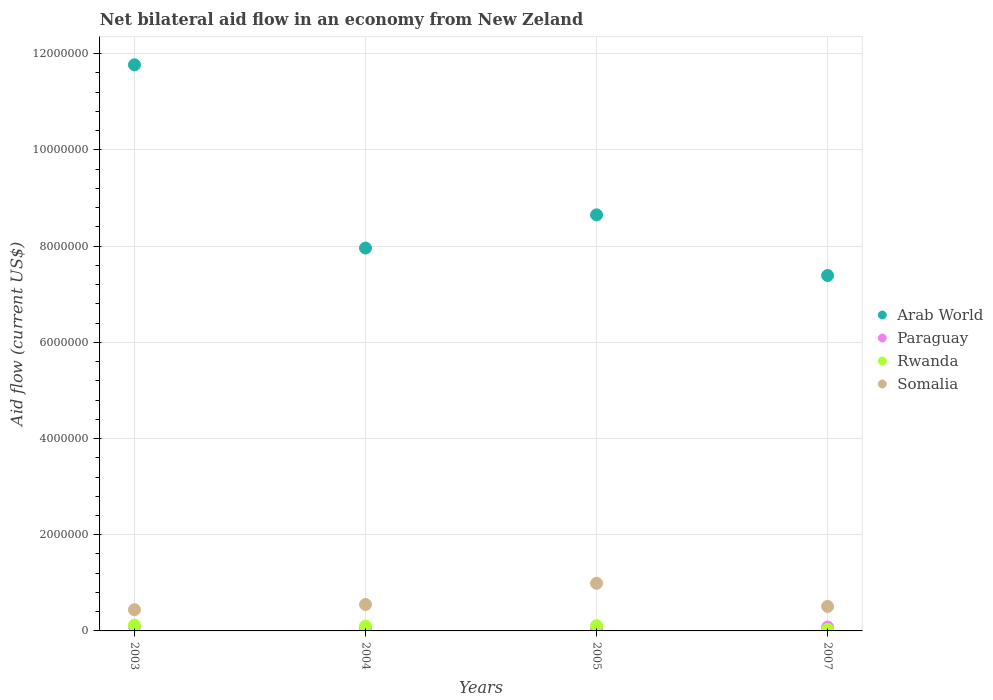How many different coloured dotlines are there?
Keep it short and to the point. 4. Is the number of dotlines equal to the number of legend labels?
Your response must be concise. Yes. What is the net bilateral aid flow in Paraguay in 2003?
Offer a very short reply. 9.00e+04. Across all years, what is the maximum net bilateral aid flow in Rwanda?
Keep it short and to the point. 1.20e+05. Across all years, what is the minimum net bilateral aid flow in Arab World?
Your answer should be very brief. 7.39e+06. In which year was the net bilateral aid flow in Paraguay maximum?
Your answer should be very brief. 2003. What is the total net bilateral aid flow in Somalia in the graph?
Your response must be concise. 2.49e+06. What is the difference between the net bilateral aid flow in Rwanda in 2005 and that in 2007?
Your response must be concise. 8.00e+04. What is the difference between the net bilateral aid flow in Somalia in 2004 and the net bilateral aid flow in Paraguay in 2007?
Your answer should be compact. 4.70e+05. In the year 2007, what is the difference between the net bilateral aid flow in Somalia and net bilateral aid flow in Arab World?
Provide a succinct answer. -6.88e+06. What is the ratio of the net bilateral aid flow in Rwanda in 2003 to that in 2005?
Your answer should be compact. 1.09. Is the difference between the net bilateral aid flow in Somalia in 2003 and 2005 greater than the difference between the net bilateral aid flow in Arab World in 2003 and 2005?
Ensure brevity in your answer.  No. In how many years, is the net bilateral aid flow in Arab World greater than the average net bilateral aid flow in Arab World taken over all years?
Make the answer very short. 1. Is the sum of the net bilateral aid flow in Rwanda in 2004 and 2005 greater than the maximum net bilateral aid flow in Somalia across all years?
Make the answer very short. No. Is it the case that in every year, the sum of the net bilateral aid flow in Somalia and net bilateral aid flow in Rwanda  is greater than the sum of net bilateral aid flow in Paraguay and net bilateral aid flow in Arab World?
Your answer should be very brief. No. Is it the case that in every year, the sum of the net bilateral aid flow in Arab World and net bilateral aid flow in Somalia  is greater than the net bilateral aid flow in Rwanda?
Ensure brevity in your answer.  Yes. Does the net bilateral aid flow in Paraguay monotonically increase over the years?
Your answer should be compact. No. Is the net bilateral aid flow in Somalia strictly greater than the net bilateral aid flow in Paraguay over the years?
Your response must be concise. Yes. What is the difference between two consecutive major ticks on the Y-axis?
Your answer should be very brief. 2.00e+06. Are the values on the major ticks of Y-axis written in scientific E-notation?
Your answer should be very brief. No. Does the graph contain any zero values?
Provide a short and direct response. No. Does the graph contain grids?
Your response must be concise. Yes. How many legend labels are there?
Offer a very short reply. 4. What is the title of the graph?
Your answer should be very brief. Net bilateral aid flow in an economy from New Zeland. Does "Turks and Caicos Islands" appear as one of the legend labels in the graph?
Keep it short and to the point. No. What is the Aid flow (current US$) in Arab World in 2003?
Ensure brevity in your answer.  1.18e+07. What is the Aid flow (current US$) of Paraguay in 2003?
Your answer should be very brief. 9.00e+04. What is the Aid flow (current US$) of Rwanda in 2003?
Give a very brief answer. 1.20e+05. What is the Aid flow (current US$) of Arab World in 2004?
Provide a short and direct response. 7.96e+06. What is the Aid flow (current US$) of Paraguay in 2004?
Provide a short and direct response. 6.00e+04. What is the Aid flow (current US$) in Rwanda in 2004?
Ensure brevity in your answer.  1.00e+05. What is the Aid flow (current US$) in Arab World in 2005?
Ensure brevity in your answer.  8.65e+06. What is the Aid flow (current US$) of Paraguay in 2005?
Offer a very short reply. 5.00e+04. What is the Aid flow (current US$) in Rwanda in 2005?
Make the answer very short. 1.10e+05. What is the Aid flow (current US$) of Somalia in 2005?
Offer a very short reply. 9.90e+05. What is the Aid flow (current US$) of Arab World in 2007?
Offer a terse response. 7.39e+06. What is the Aid flow (current US$) in Paraguay in 2007?
Your answer should be very brief. 8.00e+04. What is the Aid flow (current US$) of Somalia in 2007?
Offer a terse response. 5.10e+05. Across all years, what is the maximum Aid flow (current US$) of Arab World?
Keep it short and to the point. 1.18e+07. Across all years, what is the maximum Aid flow (current US$) in Paraguay?
Ensure brevity in your answer.  9.00e+04. Across all years, what is the maximum Aid flow (current US$) in Somalia?
Offer a terse response. 9.90e+05. Across all years, what is the minimum Aid flow (current US$) in Arab World?
Keep it short and to the point. 7.39e+06. Across all years, what is the minimum Aid flow (current US$) of Rwanda?
Offer a terse response. 3.00e+04. What is the total Aid flow (current US$) in Arab World in the graph?
Ensure brevity in your answer.  3.58e+07. What is the total Aid flow (current US$) of Paraguay in the graph?
Ensure brevity in your answer.  2.80e+05. What is the total Aid flow (current US$) of Somalia in the graph?
Your answer should be compact. 2.49e+06. What is the difference between the Aid flow (current US$) of Arab World in 2003 and that in 2004?
Ensure brevity in your answer.  3.81e+06. What is the difference between the Aid flow (current US$) in Rwanda in 2003 and that in 2004?
Provide a succinct answer. 2.00e+04. What is the difference between the Aid flow (current US$) in Somalia in 2003 and that in 2004?
Keep it short and to the point. -1.10e+05. What is the difference between the Aid flow (current US$) in Arab World in 2003 and that in 2005?
Your answer should be compact. 3.12e+06. What is the difference between the Aid flow (current US$) in Paraguay in 2003 and that in 2005?
Your response must be concise. 4.00e+04. What is the difference between the Aid flow (current US$) in Somalia in 2003 and that in 2005?
Make the answer very short. -5.50e+05. What is the difference between the Aid flow (current US$) in Arab World in 2003 and that in 2007?
Offer a very short reply. 4.38e+06. What is the difference between the Aid flow (current US$) in Rwanda in 2003 and that in 2007?
Keep it short and to the point. 9.00e+04. What is the difference between the Aid flow (current US$) of Somalia in 2003 and that in 2007?
Ensure brevity in your answer.  -7.00e+04. What is the difference between the Aid flow (current US$) in Arab World in 2004 and that in 2005?
Ensure brevity in your answer.  -6.90e+05. What is the difference between the Aid flow (current US$) in Paraguay in 2004 and that in 2005?
Your response must be concise. 10000. What is the difference between the Aid flow (current US$) in Rwanda in 2004 and that in 2005?
Your answer should be compact. -10000. What is the difference between the Aid flow (current US$) of Somalia in 2004 and that in 2005?
Keep it short and to the point. -4.40e+05. What is the difference between the Aid flow (current US$) in Arab World in 2004 and that in 2007?
Your answer should be compact. 5.70e+05. What is the difference between the Aid flow (current US$) of Rwanda in 2004 and that in 2007?
Give a very brief answer. 7.00e+04. What is the difference between the Aid flow (current US$) of Somalia in 2004 and that in 2007?
Provide a succinct answer. 4.00e+04. What is the difference between the Aid flow (current US$) in Arab World in 2005 and that in 2007?
Make the answer very short. 1.26e+06. What is the difference between the Aid flow (current US$) of Rwanda in 2005 and that in 2007?
Offer a very short reply. 8.00e+04. What is the difference between the Aid flow (current US$) in Arab World in 2003 and the Aid flow (current US$) in Paraguay in 2004?
Make the answer very short. 1.17e+07. What is the difference between the Aid flow (current US$) of Arab World in 2003 and the Aid flow (current US$) of Rwanda in 2004?
Offer a terse response. 1.17e+07. What is the difference between the Aid flow (current US$) of Arab World in 2003 and the Aid flow (current US$) of Somalia in 2004?
Your answer should be very brief. 1.12e+07. What is the difference between the Aid flow (current US$) in Paraguay in 2003 and the Aid flow (current US$) in Rwanda in 2004?
Your answer should be compact. -10000. What is the difference between the Aid flow (current US$) of Paraguay in 2003 and the Aid flow (current US$) of Somalia in 2004?
Offer a terse response. -4.60e+05. What is the difference between the Aid flow (current US$) of Rwanda in 2003 and the Aid flow (current US$) of Somalia in 2004?
Give a very brief answer. -4.30e+05. What is the difference between the Aid flow (current US$) in Arab World in 2003 and the Aid flow (current US$) in Paraguay in 2005?
Offer a terse response. 1.17e+07. What is the difference between the Aid flow (current US$) in Arab World in 2003 and the Aid flow (current US$) in Rwanda in 2005?
Offer a terse response. 1.17e+07. What is the difference between the Aid flow (current US$) in Arab World in 2003 and the Aid flow (current US$) in Somalia in 2005?
Your response must be concise. 1.08e+07. What is the difference between the Aid flow (current US$) in Paraguay in 2003 and the Aid flow (current US$) in Rwanda in 2005?
Give a very brief answer. -2.00e+04. What is the difference between the Aid flow (current US$) in Paraguay in 2003 and the Aid flow (current US$) in Somalia in 2005?
Offer a terse response. -9.00e+05. What is the difference between the Aid flow (current US$) of Rwanda in 2003 and the Aid flow (current US$) of Somalia in 2005?
Offer a terse response. -8.70e+05. What is the difference between the Aid flow (current US$) in Arab World in 2003 and the Aid flow (current US$) in Paraguay in 2007?
Make the answer very short. 1.17e+07. What is the difference between the Aid flow (current US$) in Arab World in 2003 and the Aid flow (current US$) in Rwanda in 2007?
Provide a succinct answer. 1.17e+07. What is the difference between the Aid flow (current US$) of Arab World in 2003 and the Aid flow (current US$) of Somalia in 2007?
Provide a short and direct response. 1.13e+07. What is the difference between the Aid flow (current US$) of Paraguay in 2003 and the Aid flow (current US$) of Somalia in 2007?
Your response must be concise. -4.20e+05. What is the difference between the Aid flow (current US$) of Rwanda in 2003 and the Aid flow (current US$) of Somalia in 2007?
Keep it short and to the point. -3.90e+05. What is the difference between the Aid flow (current US$) of Arab World in 2004 and the Aid flow (current US$) of Paraguay in 2005?
Provide a succinct answer. 7.91e+06. What is the difference between the Aid flow (current US$) of Arab World in 2004 and the Aid flow (current US$) of Rwanda in 2005?
Keep it short and to the point. 7.85e+06. What is the difference between the Aid flow (current US$) of Arab World in 2004 and the Aid flow (current US$) of Somalia in 2005?
Give a very brief answer. 6.97e+06. What is the difference between the Aid flow (current US$) of Paraguay in 2004 and the Aid flow (current US$) of Somalia in 2005?
Make the answer very short. -9.30e+05. What is the difference between the Aid flow (current US$) of Rwanda in 2004 and the Aid flow (current US$) of Somalia in 2005?
Your answer should be very brief. -8.90e+05. What is the difference between the Aid flow (current US$) of Arab World in 2004 and the Aid flow (current US$) of Paraguay in 2007?
Make the answer very short. 7.88e+06. What is the difference between the Aid flow (current US$) in Arab World in 2004 and the Aid flow (current US$) in Rwanda in 2007?
Provide a short and direct response. 7.93e+06. What is the difference between the Aid flow (current US$) in Arab World in 2004 and the Aid flow (current US$) in Somalia in 2007?
Provide a short and direct response. 7.45e+06. What is the difference between the Aid flow (current US$) in Paraguay in 2004 and the Aid flow (current US$) in Somalia in 2007?
Ensure brevity in your answer.  -4.50e+05. What is the difference between the Aid flow (current US$) in Rwanda in 2004 and the Aid flow (current US$) in Somalia in 2007?
Offer a very short reply. -4.10e+05. What is the difference between the Aid flow (current US$) of Arab World in 2005 and the Aid flow (current US$) of Paraguay in 2007?
Provide a succinct answer. 8.57e+06. What is the difference between the Aid flow (current US$) of Arab World in 2005 and the Aid flow (current US$) of Rwanda in 2007?
Your response must be concise. 8.62e+06. What is the difference between the Aid flow (current US$) of Arab World in 2005 and the Aid flow (current US$) of Somalia in 2007?
Make the answer very short. 8.14e+06. What is the difference between the Aid flow (current US$) in Paraguay in 2005 and the Aid flow (current US$) in Somalia in 2007?
Offer a very short reply. -4.60e+05. What is the difference between the Aid flow (current US$) of Rwanda in 2005 and the Aid flow (current US$) of Somalia in 2007?
Your answer should be very brief. -4.00e+05. What is the average Aid flow (current US$) in Arab World per year?
Offer a very short reply. 8.94e+06. What is the average Aid flow (current US$) of Somalia per year?
Provide a succinct answer. 6.22e+05. In the year 2003, what is the difference between the Aid flow (current US$) in Arab World and Aid flow (current US$) in Paraguay?
Provide a short and direct response. 1.17e+07. In the year 2003, what is the difference between the Aid flow (current US$) in Arab World and Aid flow (current US$) in Rwanda?
Ensure brevity in your answer.  1.16e+07. In the year 2003, what is the difference between the Aid flow (current US$) of Arab World and Aid flow (current US$) of Somalia?
Make the answer very short. 1.13e+07. In the year 2003, what is the difference between the Aid flow (current US$) of Paraguay and Aid flow (current US$) of Rwanda?
Your response must be concise. -3.00e+04. In the year 2003, what is the difference between the Aid flow (current US$) in Paraguay and Aid flow (current US$) in Somalia?
Your answer should be very brief. -3.50e+05. In the year 2003, what is the difference between the Aid flow (current US$) of Rwanda and Aid flow (current US$) of Somalia?
Offer a very short reply. -3.20e+05. In the year 2004, what is the difference between the Aid flow (current US$) in Arab World and Aid flow (current US$) in Paraguay?
Make the answer very short. 7.90e+06. In the year 2004, what is the difference between the Aid flow (current US$) in Arab World and Aid flow (current US$) in Rwanda?
Give a very brief answer. 7.86e+06. In the year 2004, what is the difference between the Aid flow (current US$) in Arab World and Aid flow (current US$) in Somalia?
Offer a very short reply. 7.41e+06. In the year 2004, what is the difference between the Aid flow (current US$) of Paraguay and Aid flow (current US$) of Somalia?
Keep it short and to the point. -4.90e+05. In the year 2004, what is the difference between the Aid flow (current US$) in Rwanda and Aid flow (current US$) in Somalia?
Your answer should be compact. -4.50e+05. In the year 2005, what is the difference between the Aid flow (current US$) of Arab World and Aid flow (current US$) of Paraguay?
Your answer should be compact. 8.60e+06. In the year 2005, what is the difference between the Aid flow (current US$) of Arab World and Aid flow (current US$) of Rwanda?
Keep it short and to the point. 8.54e+06. In the year 2005, what is the difference between the Aid flow (current US$) in Arab World and Aid flow (current US$) in Somalia?
Keep it short and to the point. 7.66e+06. In the year 2005, what is the difference between the Aid flow (current US$) of Paraguay and Aid flow (current US$) of Rwanda?
Keep it short and to the point. -6.00e+04. In the year 2005, what is the difference between the Aid flow (current US$) of Paraguay and Aid flow (current US$) of Somalia?
Offer a very short reply. -9.40e+05. In the year 2005, what is the difference between the Aid flow (current US$) of Rwanda and Aid flow (current US$) of Somalia?
Provide a short and direct response. -8.80e+05. In the year 2007, what is the difference between the Aid flow (current US$) of Arab World and Aid flow (current US$) of Paraguay?
Keep it short and to the point. 7.31e+06. In the year 2007, what is the difference between the Aid flow (current US$) of Arab World and Aid flow (current US$) of Rwanda?
Offer a very short reply. 7.36e+06. In the year 2007, what is the difference between the Aid flow (current US$) of Arab World and Aid flow (current US$) of Somalia?
Keep it short and to the point. 6.88e+06. In the year 2007, what is the difference between the Aid flow (current US$) of Paraguay and Aid flow (current US$) of Rwanda?
Give a very brief answer. 5.00e+04. In the year 2007, what is the difference between the Aid flow (current US$) in Paraguay and Aid flow (current US$) in Somalia?
Offer a very short reply. -4.30e+05. In the year 2007, what is the difference between the Aid flow (current US$) in Rwanda and Aid flow (current US$) in Somalia?
Ensure brevity in your answer.  -4.80e+05. What is the ratio of the Aid flow (current US$) in Arab World in 2003 to that in 2004?
Your answer should be compact. 1.48. What is the ratio of the Aid flow (current US$) of Paraguay in 2003 to that in 2004?
Provide a succinct answer. 1.5. What is the ratio of the Aid flow (current US$) of Rwanda in 2003 to that in 2004?
Your response must be concise. 1.2. What is the ratio of the Aid flow (current US$) of Somalia in 2003 to that in 2004?
Give a very brief answer. 0.8. What is the ratio of the Aid flow (current US$) in Arab World in 2003 to that in 2005?
Ensure brevity in your answer.  1.36. What is the ratio of the Aid flow (current US$) in Paraguay in 2003 to that in 2005?
Provide a succinct answer. 1.8. What is the ratio of the Aid flow (current US$) in Rwanda in 2003 to that in 2005?
Your response must be concise. 1.09. What is the ratio of the Aid flow (current US$) of Somalia in 2003 to that in 2005?
Provide a succinct answer. 0.44. What is the ratio of the Aid flow (current US$) in Arab World in 2003 to that in 2007?
Your response must be concise. 1.59. What is the ratio of the Aid flow (current US$) in Paraguay in 2003 to that in 2007?
Your answer should be very brief. 1.12. What is the ratio of the Aid flow (current US$) in Rwanda in 2003 to that in 2007?
Offer a very short reply. 4. What is the ratio of the Aid flow (current US$) of Somalia in 2003 to that in 2007?
Offer a very short reply. 0.86. What is the ratio of the Aid flow (current US$) of Arab World in 2004 to that in 2005?
Your answer should be very brief. 0.92. What is the ratio of the Aid flow (current US$) of Paraguay in 2004 to that in 2005?
Give a very brief answer. 1.2. What is the ratio of the Aid flow (current US$) in Somalia in 2004 to that in 2005?
Give a very brief answer. 0.56. What is the ratio of the Aid flow (current US$) in Arab World in 2004 to that in 2007?
Your response must be concise. 1.08. What is the ratio of the Aid flow (current US$) of Paraguay in 2004 to that in 2007?
Ensure brevity in your answer.  0.75. What is the ratio of the Aid flow (current US$) of Rwanda in 2004 to that in 2007?
Your answer should be very brief. 3.33. What is the ratio of the Aid flow (current US$) in Somalia in 2004 to that in 2007?
Your answer should be very brief. 1.08. What is the ratio of the Aid flow (current US$) of Arab World in 2005 to that in 2007?
Your response must be concise. 1.17. What is the ratio of the Aid flow (current US$) of Rwanda in 2005 to that in 2007?
Keep it short and to the point. 3.67. What is the ratio of the Aid flow (current US$) of Somalia in 2005 to that in 2007?
Make the answer very short. 1.94. What is the difference between the highest and the second highest Aid flow (current US$) in Arab World?
Your response must be concise. 3.12e+06. What is the difference between the highest and the second highest Aid flow (current US$) in Paraguay?
Keep it short and to the point. 10000. What is the difference between the highest and the second highest Aid flow (current US$) in Somalia?
Offer a very short reply. 4.40e+05. What is the difference between the highest and the lowest Aid flow (current US$) in Arab World?
Keep it short and to the point. 4.38e+06. What is the difference between the highest and the lowest Aid flow (current US$) of Paraguay?
Your answer should be compact. 4.00e+04. What is the difference between the highest and the lowest Aid flow (current US$) of Somalia?
Offer a very short reply. 5.50e+05. 